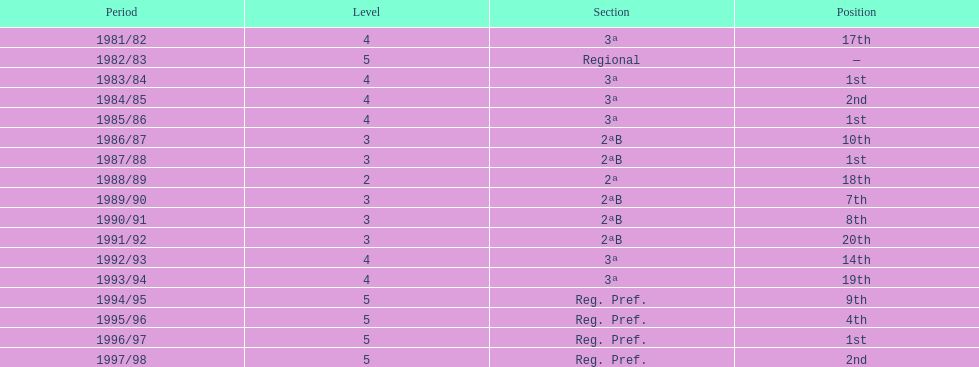How many times total did they finish first 4. 